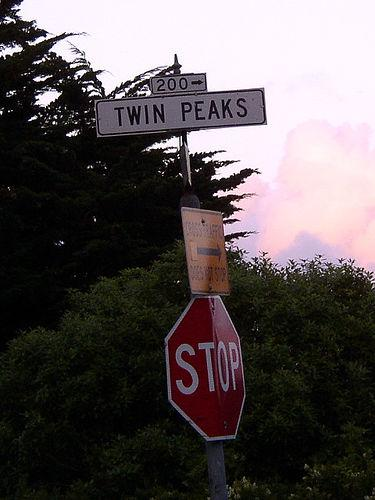Question: how many stop signs are there?
Choices:
A. 12.
B. 1.
C. 13.
D. 5.
Answer with the letter. Answer: B Question: where was the photo taken?
Choices:
A. The street.
B. The sidewalk.
C. Next to a building.
D. At an intersection.
Answer with the letter. Answer: D Question: what says stop?
Choices:
A. The sign.
B. The wall.
C. The video game.
D. The game board.
Answer with the letter. Answer: A Question: what is green?
Choices:
A. The grass.
B. The trees.
C. The bushes.
D. The garden.
Answer with the letter. Answer: C Question: why is it so bright?
Choices:
A. Sun light.
B. All surroundings are light colored.
C. Many lights are on.
D. They are outside.
Answer with the letter. Answer: A Question: what color is the 200 sign?
Choices:
A. Teal.
B. Purple.
C. White.
D. Neon.
Answer with the letter. Answer: C 